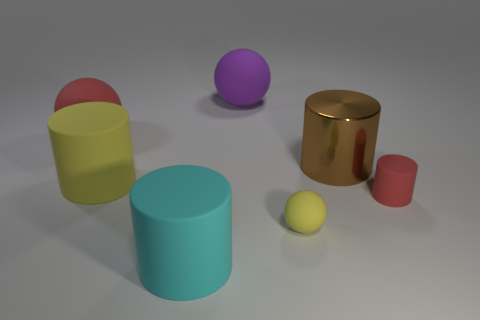Can you describe the shapes of the objects seen in the image? Certainly! In the image, there are various geometric shapes: a sphere, a couple of cylinders, and a cylinder with a concave feature that could be described as a cup or a container with a handle.  What colors do the objects have, and how many objects are there for each color? The objects exhibit an assortment of colors. There's one purple sphere, one yellow sphere, one pinkish-red cylinder, one mint green cylinder, and two gold colored objects, one of which is a cylinder and the other looks like a container or a cup. 